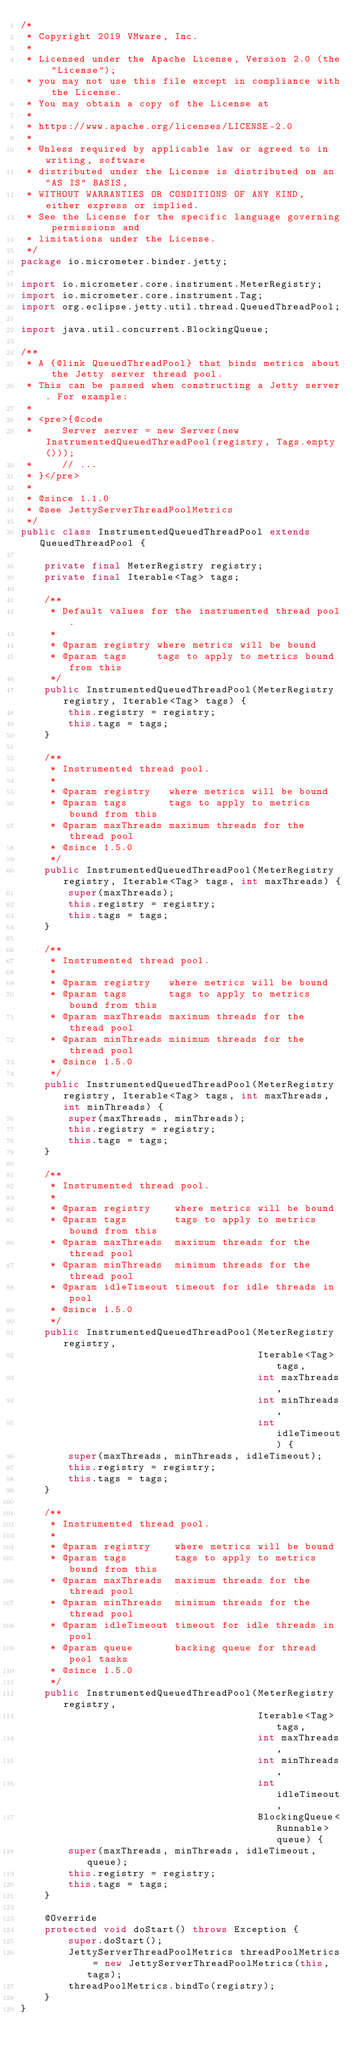<code> <loc_0><loc_0><loc_500><loc_500><_Java_>/*
 * Copyright 2019 VMware, Inc.
 *
 * Licensed under the Apache License, Version 2.0 (the "License");
 * you may not use this file except in compliance with the License.
 * You may obtain a copy of the License at
 *
 * https://www.apache.org/licenses/LICENSE-2.0
 *
 * Unless required by applicable law or agreed to in writing, software
 * distributed under the License is distributed on an "AS IS" BASIS,
 * WITHOUT WARRANTIES OR CONDITIONS OF ANY KIND, either express or implied.
 * See the License for the specific language governing permissions and
 * limitations under the License.
 */
package io.micrometer.binder.jetty;

import io.micrometer.core.instrument.MeterRegistry;
import io.micrometer.core.instrument.Tag;
import org.eclipse.jetty.util.thread.QueuedThreadPool;

import java.util.concurrent.BlockingQueue;

/**
 * A {@link QueuedThreadPool} that binds metrics about the Jetty server thread pool.
 * This can be passed when constructing a Jetty server. For example:
 *
 * <pre>{@code
 *     Server server = new Server(new InstrumentedQueuedThreadPool(registry, Tags.empty()));
 *     // ...
 * }</pre>
 *
 * @since 1.1.0
 * @see JettyServerThreadPoolMetrics
 */
public class InstrumentedQueuedThreadPool extends QueuedThreadPool {

    private final MeterRegistry registry;
    private final Iterable<Tag> tags;

    /**
     * Default values for the instrumented thread pool.
     *
     * @param registry where metrics will be bound
     * @param tags     tags to apply to metrics bound from this
     */
    public InstrumentedQueuedThreadPool(MeterRegistry registry, Iterable<Tag> tags) {
        this.registry = registry;
        this.tags = tags;
    }

    /**
     * Instrumented thread pool.
     *
     * @param registry   where metrics will be bound
     * @param tags       tags to apply to metrics bound from this
     * @param maxThreads maximum threads for the thread pool
     * @since 1.5.0
     */
    public InstrumentedQueuedThreadPool(MeterRegistry registry, Iterable<Tag> tags, int maxThreads) {
        super(maxThreads);
        this.registry = registry;
        this.tags = tags;
    }

    /**
     * Instrumented thread pool.
     *
     * @param registry   where metrics will be bound
     * @param tags       tags to apply to metrics bound from this
     * @param maxThreads maximum threads for the thread pool
     * @param minThreads minimum threads for the thread pool
     * @since 1.5.0
     */
    public InstrumentedQueuedThreadPool(MeterRegistry registry, Iterable<Tag> tags, int maxThreads, int minThreads) {
        super(maxThreads, minThreads);
        this.registry = registry;
        this.tags = tags;
    }

    /**
     * Instrumented thread pool.
     *
     * @param registry    where metrics will be bound
     * @param tags        tags to apply to metrics bound from this
     * @param maxThreads  maximum threads for the thread pool
     * @param minThreads  minimum threads for the thread pool
     * @param idleTimeout timeout for idle threads in pool
     * @since 1.5.0
     */
    public InstrumentedQueuedThreadPool(MeterRegistry registry,
                                        Iterable<Tag> tags,
                                        int maxThreads,
                                        int minThreads,
                                        int idleTimeout) {
        super(maxThreads, minThreads, idleTimeout);
        this.registry = registry;
        this.tags = tags;
    }

    /**
     * Instrumented thread pool.
     *
     * @param registry    where metrics will be bound
     * @param tags        tags to apply to metrics bound from this
     * @param maxThreads  maximum threads for the thread pool
     * @param minThreads  minimum threads for the thread pool
     * @param idleTimeout timeout for idle threads in pool
     * @param queue       backing queue for thread pool tasks
     * @since 1.5.0
     */
    public InstrumentedQueuedThreadPool(MeterRegistry registry,
                                        Iterable<Tag> tags,
                                        int maxThreads,
                                        int minThreads,
                                        int idleTimeout,
                                        BlockingQueue<Runnable> queue) {
        super(maxThreads, minThreads, idleTimeout, queue);
        this.registry = registry;
        this.tags = tags;
    }

    @Override
    protected void doStart() throws Exception {
        super.doStart();
        JettyServerThreadPoolMetrics threadPoolMetrics = new JettyServerThreadPoolMetrics(this, tags);
        threadPoolMetrics.bindTo(registry);
    }
}
</code> 